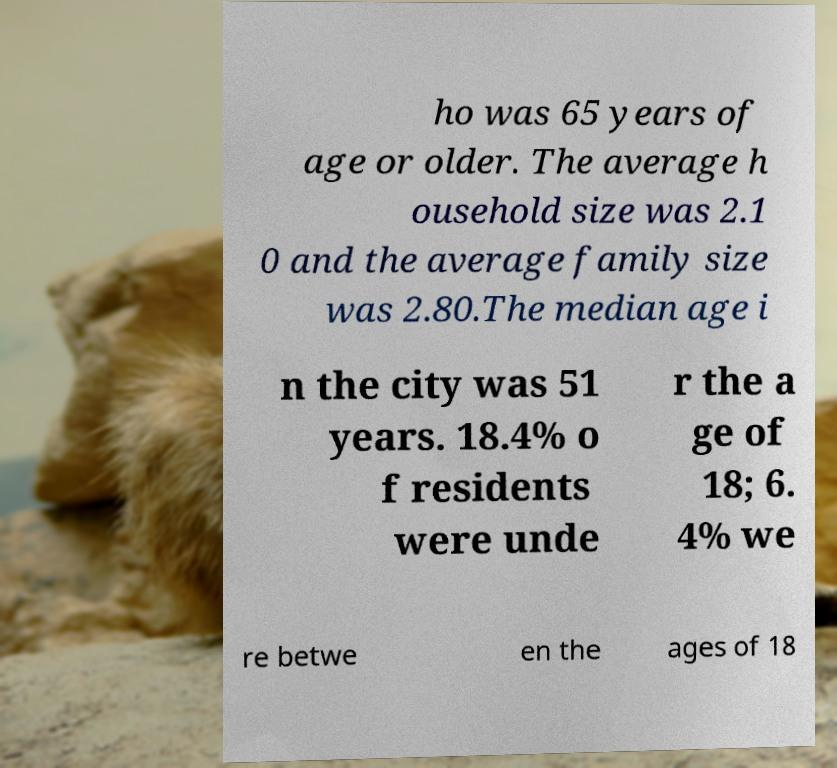For documentation purposes, I need the text within this image transcribed. Could you provide that? ho was 65 years of age or older. The average h ousehold size was 2.1 0 and the average family size was 2.80.The median age i n the city was 51 years. 18.4% o f residents were unde r the a ge of 18; 6. 4% we re betwe en the ages of 18 